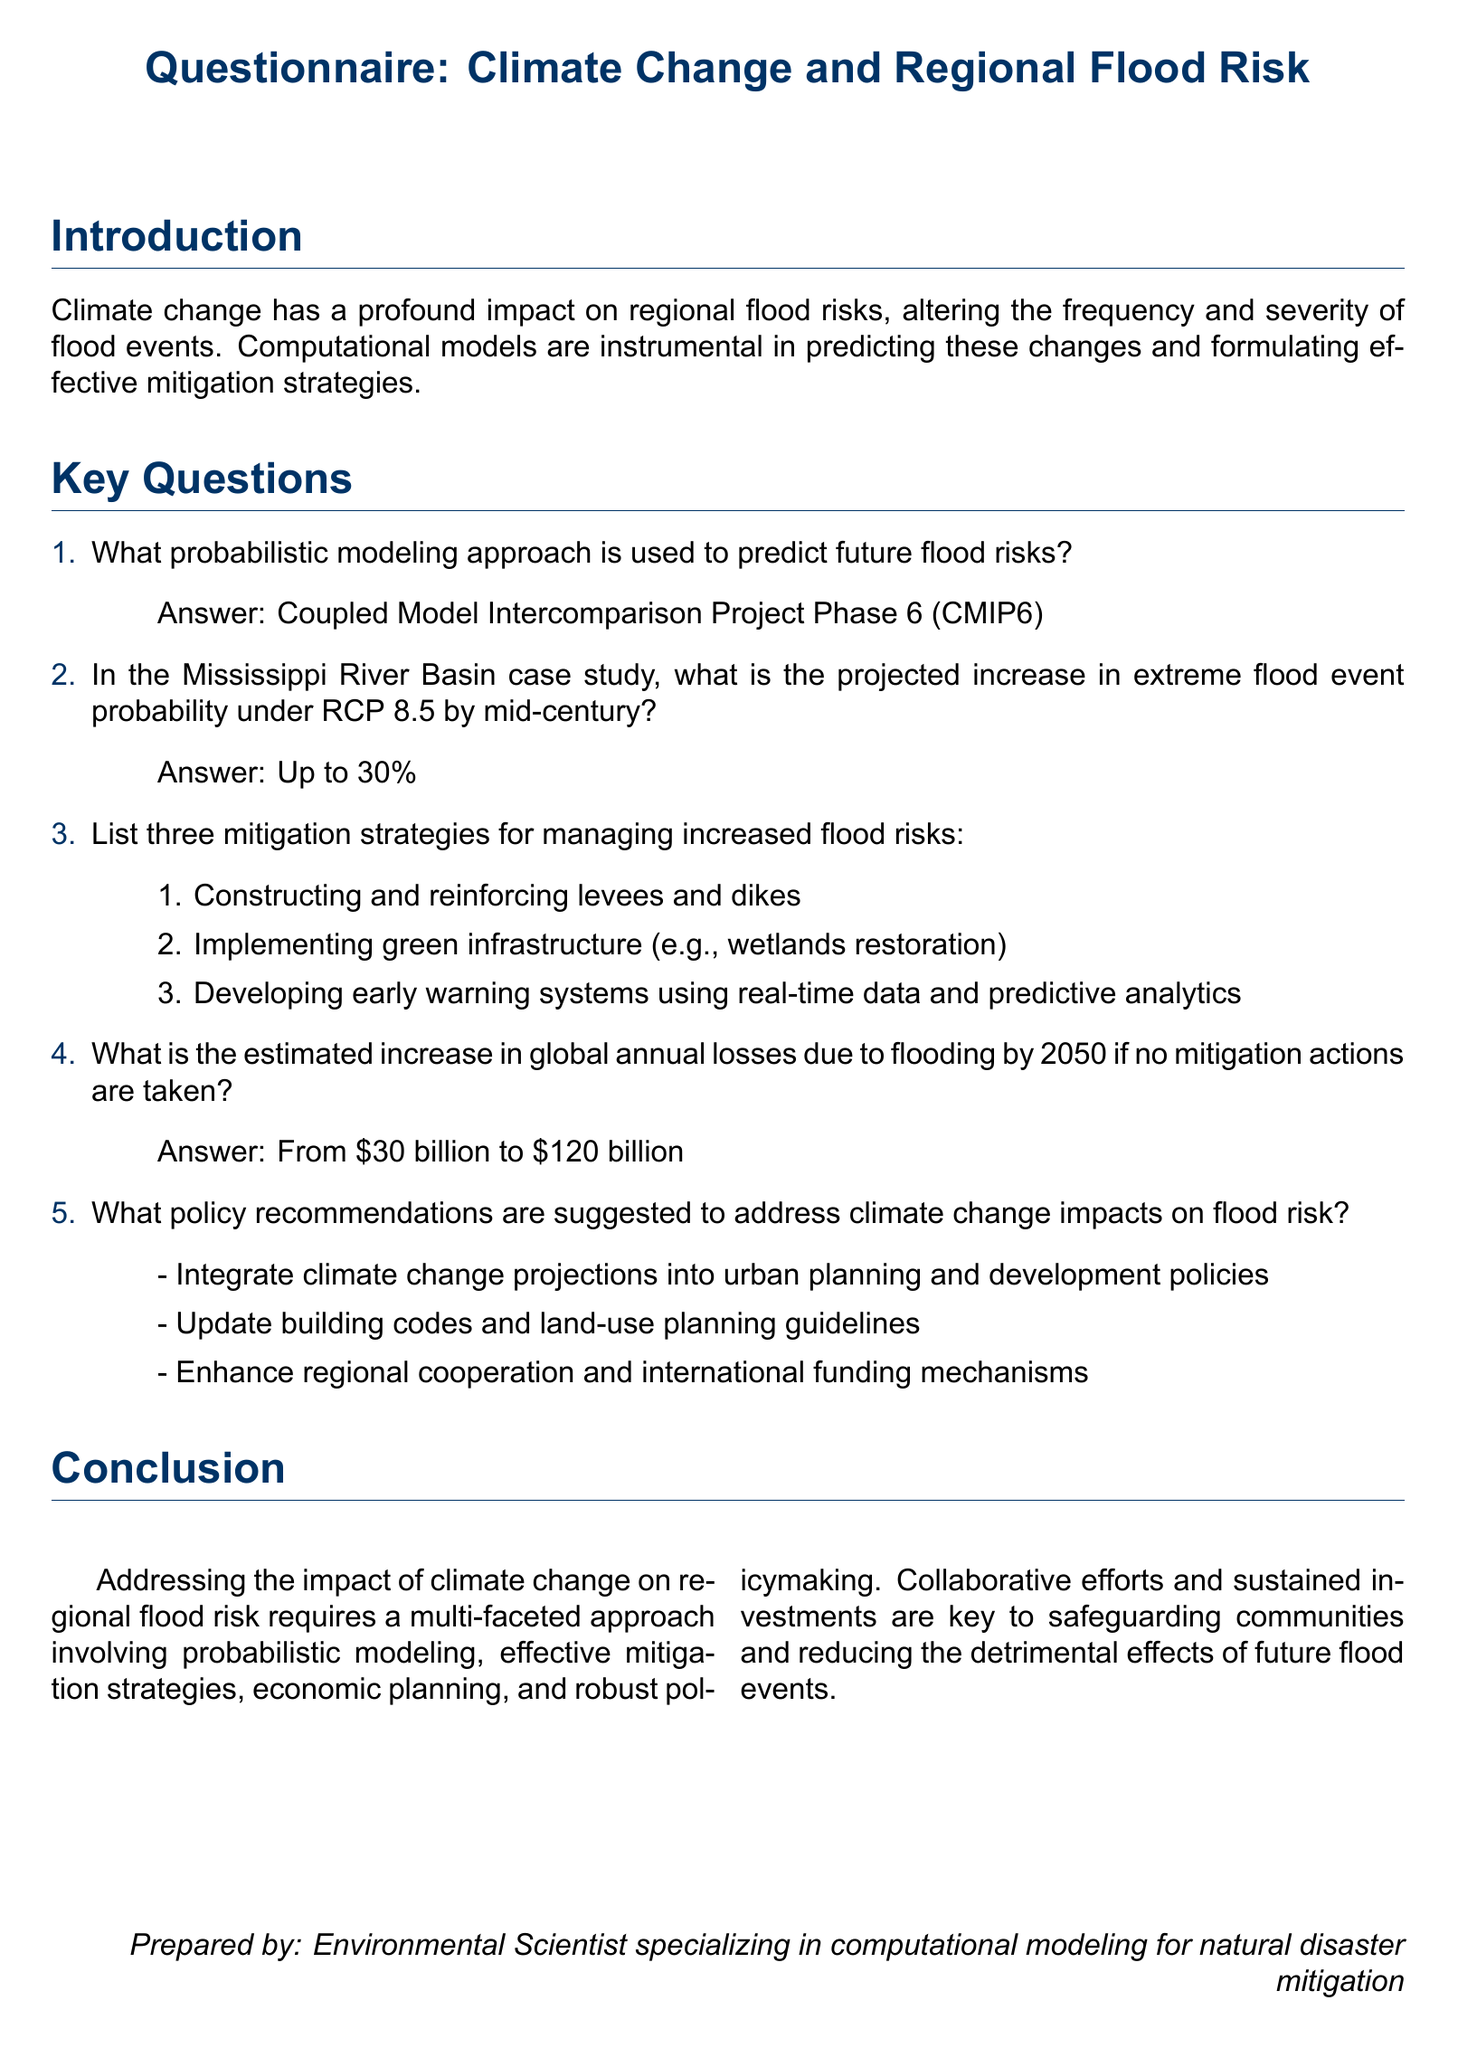What probabilistic modeling approach is used? The approach mentioned is crucial for predicting flood risks, particularly highlighted in the questionnaire.
Answer: Coupled Model Intercomparison Project Phase 6 (CMIP6) What is the projected increase in extreme flood event probability under RCP 8.5? The document specifies the percentage increase of extreme flood event probability in a specific case study scenario, which is a critical point in understanding future risks.
Answer: Up to 30% List one mitigation strategy for managing increased flood risks. The questionnaire details various strategies, and listing one shows an understanding of the potential responses to increased flood risks.
Answer: Constructing and reinforcing levees and dikes What is the estimated increase in global annual losses due to flooding by 2050? This statistic presents a financial overview of the implications of flooding, underlining the potential economic burden if mitigation actions are ignored.
Answer: From $30 billion to $120 billion What is one policy recommendation to address climate change impacts on flood risk? The questionnaire provides several recommendations, and identifying one reflects comprehension of strategic responses to the challenges posed by climate change.
Answer: Integrate climate change projections into urban planning and development policies How many mitigation strategies are listed in the document? The enumeration of strategies highlights the proactive measures that can be taken, indicating the breadth of solutions available to address flood risks.
Answer: Three What is the purpose of this document? Understanding the overall intent of the questionnaire is important, as it frames the relevance of the data provided regarding climate change and flood risks.
Answer: To assess the impact of climate change on regional flood risk 